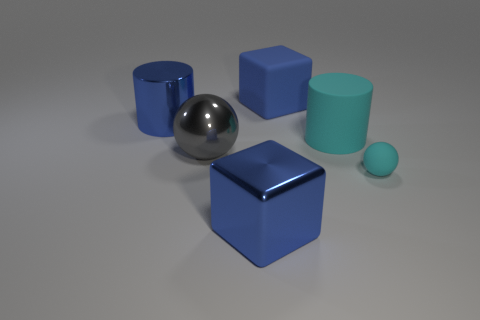Add 3 cyan metal objects. How many objects exist? 9 Subtract all blocks. How many objects are left? 4 Add 1 tiny cyan spheres. How many tiny cyan spheres are left? 2 Add 2 big purple rubber cylinders. How many big purple rubber cylinders exist? 2 Subtract 0 purple balls. How many objects are left? 6 Subtract all brown shiny things. Subtract all tiny matte spheres. How many objects are left? 5 